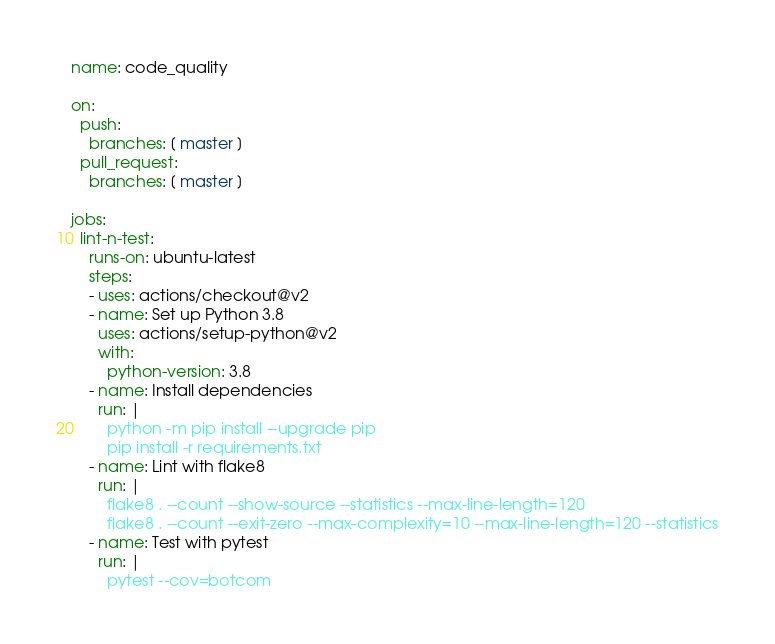Convert code to text. <code><loc_0><loc_0><loc_500><loc_500><_YAML_>name: code_quality

on:
  push:
    branches: [ master ]
  pull_request:
    branches: [ master ]

jobs:
  lint-n-test:
    runs-on: ubuntu-latest
    steps:
    - uses: actions/checkout@v2
    - name: Set up Python 3.8
      uses: actions/setup-python@v2
      with:
        python-version: 3.8
    - name: Install dependencies
      run: |
        python -m pip install --upgrade pip
        pip install -r requirements.txt
    - name: Lint with flake8
      run: |
        flake8 . --count --show-source --statistics --max-line-length=120
        flake8 . --count --exit-zero --max-complexity=10 --max-line-length=120 --statistics
    - name: Test with pytest
      run: |
        pytest --cov=botcom
</code> 